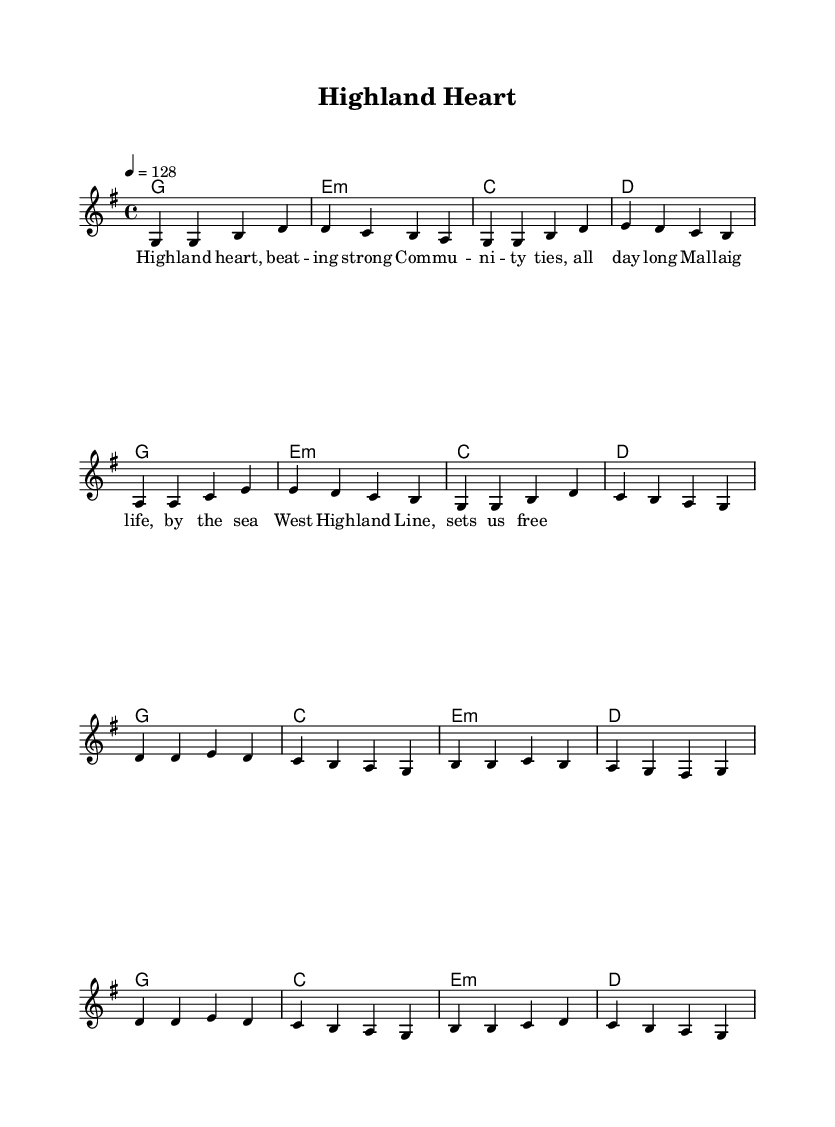What is the key signature of this music? The key signature is indicated at the beginning of the music sheet, showing one sharp. This corresponds to G major.
Answer: G major What is the time signature of the piece? The time signature appears after the key signature and is indicated by the numbers 4 and 4. This means there are four beats in a measure and the quarter note gets one beat.
Answer: 4/4 What is the tempo marking given in the piece? The tempo is specified at the start of the music with the note "4 = 128," indicating a moderate pace at 128 beats per minute.
Answer: 128 How many measures are in the melody section of the chorus? The melody for the chorus is made up of eight measures, as indicated by the rhythmic groupings. Counting the measures labeled in the notation confirms this.
Answer: 8 What type of musical piece is this? The piece exhibits characteristics typical of pop music, such as simple, catchy melodies, and themes centered around community and connection, as suggested by the lyrics.
Answer: Pop What is the first lyric line in the song? The first line of lyrics is indicated under the melody at the beginning, reading "Highland heart, beating strong." This sets the thematic tone for the song.
Answer: Highland heart, beating strong What is the harmonic progression in the verse? The harmonic progression of the verse follows a simple pattern: G, Em, C, D, repeated twice, which is typical of pop music structures in supporting melodic lines.
Answer: G, Em, C, D 